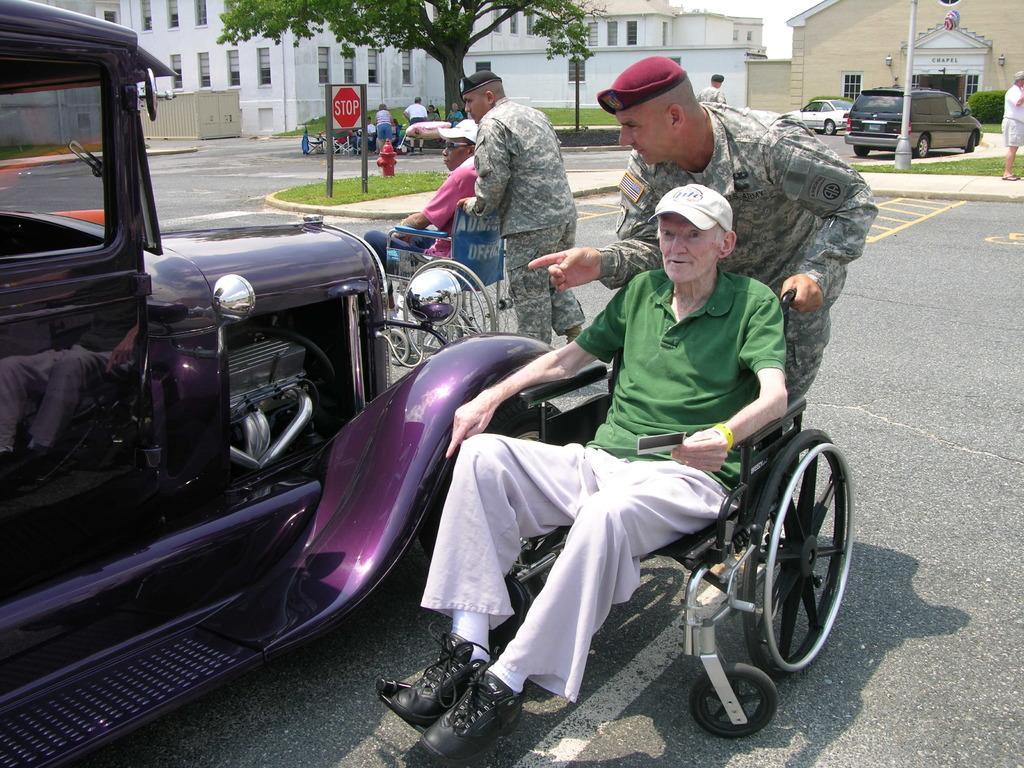Can you describe this image briefly? In this picture we can see two people sitting on the wheel chairs. Few people and some vehicles are visible on the road. We can see a signboard visible on the path. Few buildings are visible in the background. 